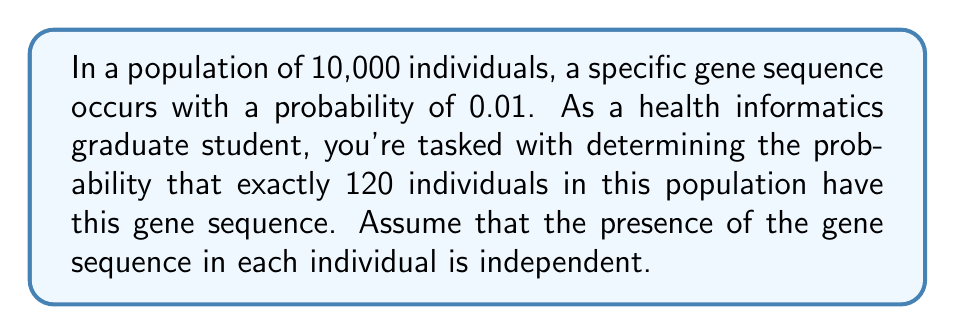Solve this math problem. To solve this problem, we'll use the binomial probability distribution, as we're dealing with a fixed number of independent trials (10,000 individuals) with two possible outcomes (having the gene sequence or not) and a constant probability of success (0.01).

Step 1: Identify the parameters
- $n$ = 10,000 (number of individuals)
- $k$ = 120 (number of successes we're interested in)
- $p$ = 0.01 (probability of success for each individual)
- $q$ = 1 - $p$ = 0.99 (probability of failure for each individual)

Step 2: Use the binomial probability formula
The probability of exactly $k$ successes in $n$ trials is given by:

$$ P(X = k) = \binom{n}{k} p^k q^{n-k} $$

Step 3: Calculate the binomial coefficient
$$ \binom{n}{k} = \binom{10000}{120} = \frac{10000!}{120!(10000-120)!} $$

Step 4: Substitute values into the formula
$$ P(X = 120) = \binom{10000}{120} (0.01)^{120} (0.99)^{9880} $$

Step 5: Compute the result
Using a calculator or computer (due to the large numbers involved):

$$ P(X = 120) \approx 0.0516 $$

This means there's approximately a 5.16% chance that exactly 120 individuals in the population have the specific gene sequence.
Answer: $0.0516$ or $5.16\%$ 